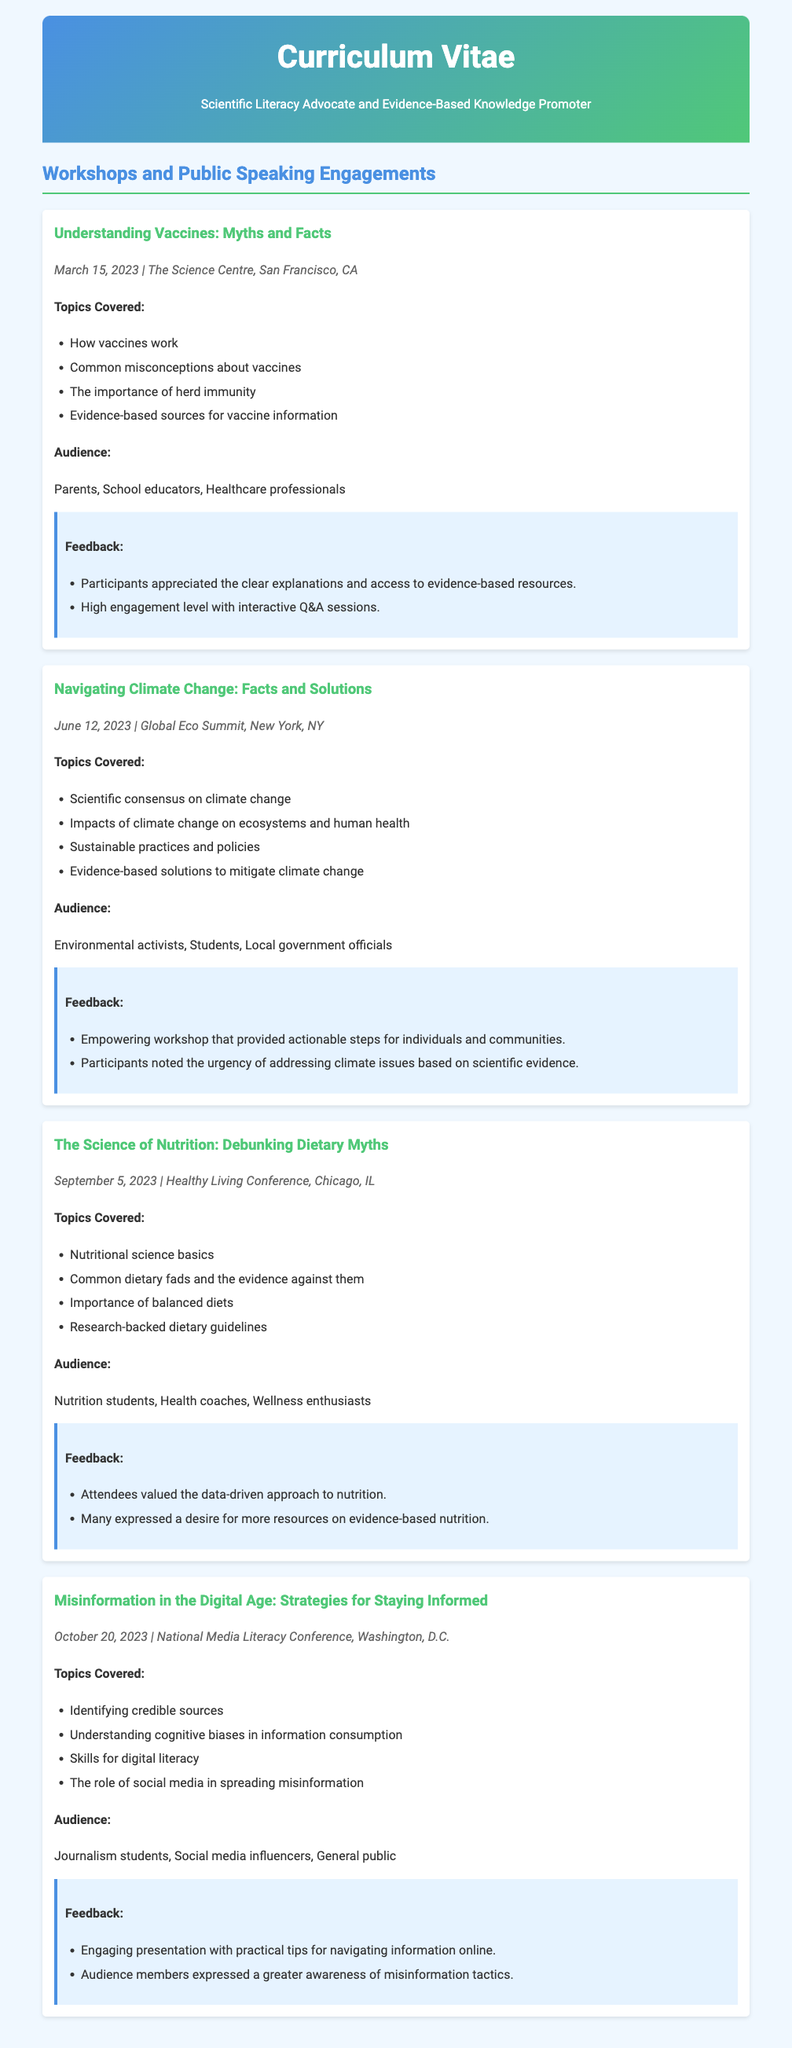What is the title of the workshop held on March 15, 2023? The title is explicitly stated as "Understanding Vaccines: Myths and Facts."
Answer: Understanding Vaccines: Myths and Facts Who was the audience for the workshop on June 12, 2023? The audience is listed as "Environmental activists, Students, Local government officials."
Answer: Environmental activists, Students, Local government officials How many topics were covered in the workshop about nutrition? The document lists four topics covered in this workshop.
Answer: 4 What key issue was addressed in the workshop titled "Misinformation in the Digital Age"? The key issue addressed is about "Identifying credible sources."
Answer: Identifying credible sources What type of feedback was received for the "Navigating Climate Change" workshop? Feedback indicates it was an "Empowering workshop that provided actionable steps for individuals and communities."
Answer: Empowering workshop that provided actionable steps for individuals and communities 